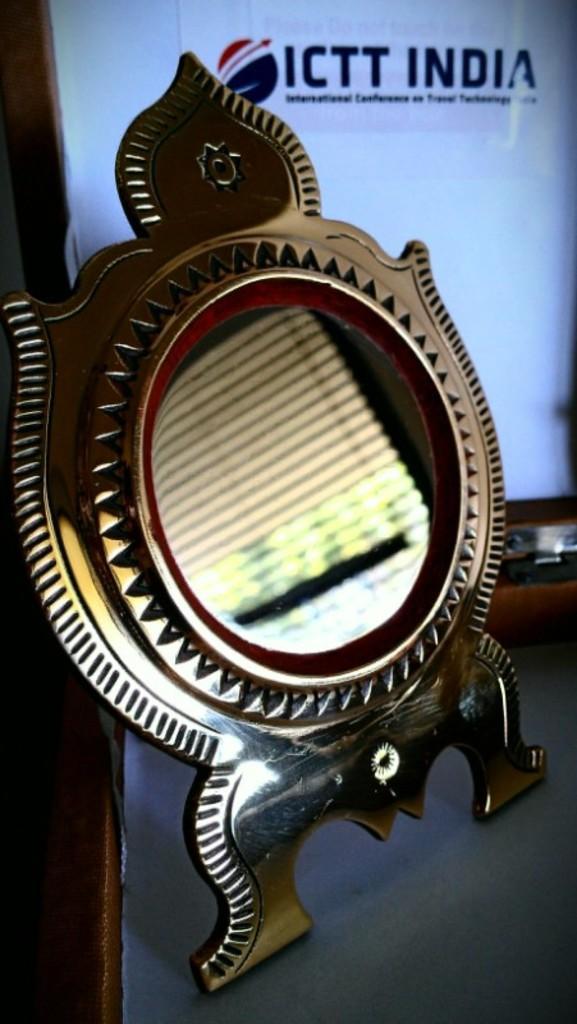In one or two sentences, can you explain what this image depicts? In this image, in the middle there is a mirror stand. In the background there is a poster, text. 